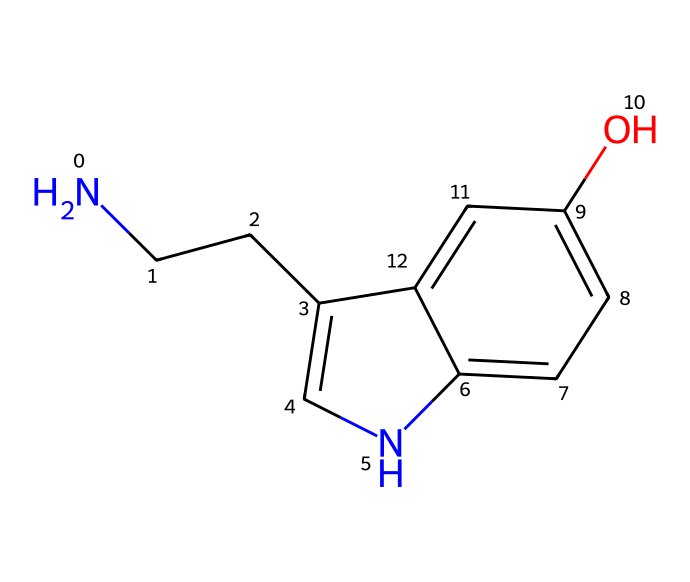What is the total number of carbon atoms in this molecule? By examining the SMILES representation, we can identify all the carbon atoms indicated by the letters 'C' in the structure. Counting them reveals that there are 10 carbon atoms.
Answer: 10 How many nitrogen atoms are present in the molecule? In the SMILES representation, the presence of 'N' indicates the nitrogen atoms. There is one 'N' in the structure, so there is one nitrogen atom.
Answer: 1 What type of functional group is present in serotonin? The presence of the -OH group in the structure indicates that this molecule possesses an alcohol functional group. Therefore, serotonin can be classified as having an alcohol functional group.
Answer: alcohol How many rings are present in the molecular structure? By analyzing the connections between atoms in the SMILES string, we can see that there are two interconnected cyclic structures in this molecule. Thus, there are two rings.
Answer: 2 What is the main role of serotonin in character development? Serotonin primarily influences mood regulation and emotional well-being, affecting how characters perceive their experiences and interact with others. Thus, its main role is in mood regulation.
Answer: mood regulation Does this molecule have any chiral centers? A chiral center is a carbon atom bonded to four different substituents, which we can check by visualizing the structure. In this case, the molecule does not exhibit any chiral centers.
Answer: no What type of molecule is serotonin classified as? Based on its structure, serotonin is classified as an amine due to the presence of the nitrogen atom giving it amine properties.
Answer: amine 